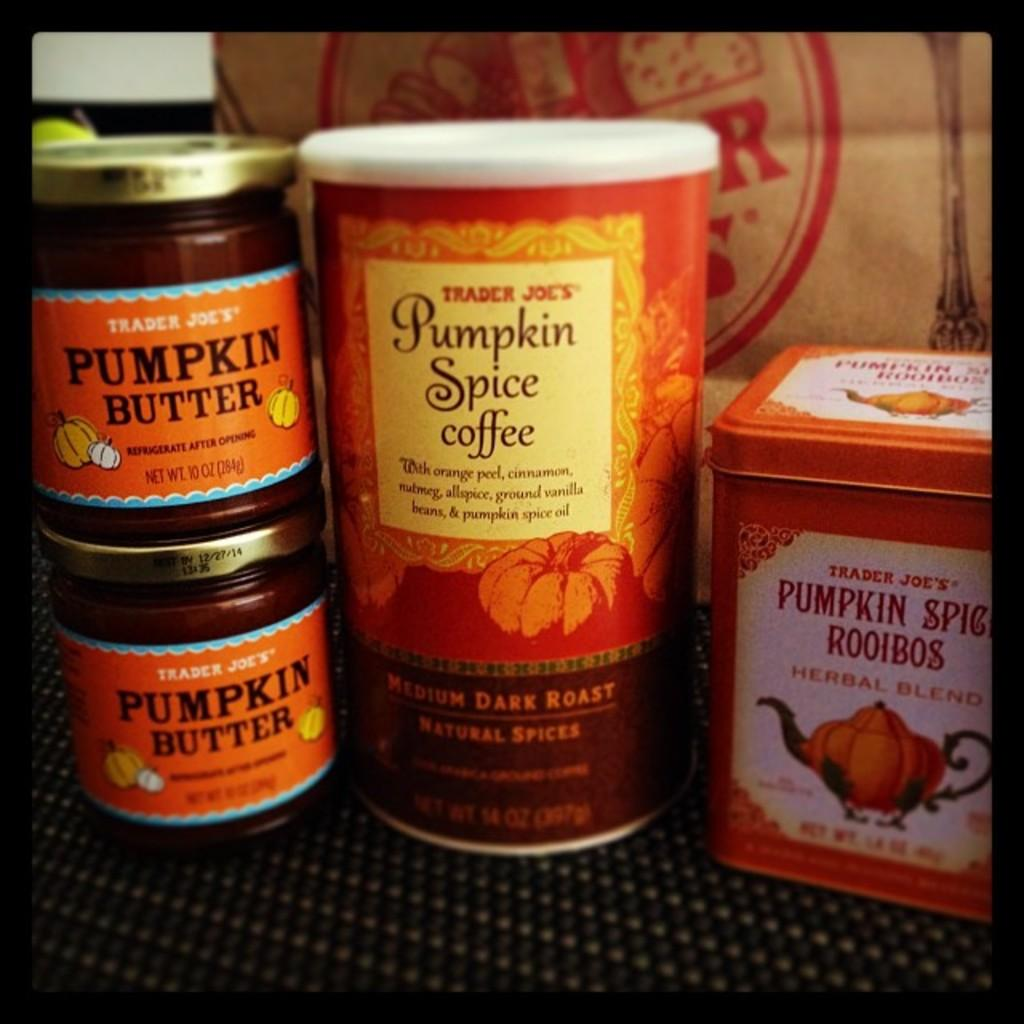<image>
Describe the image concisely. Jars on top of one another with one that says Pumpkin Butter. 